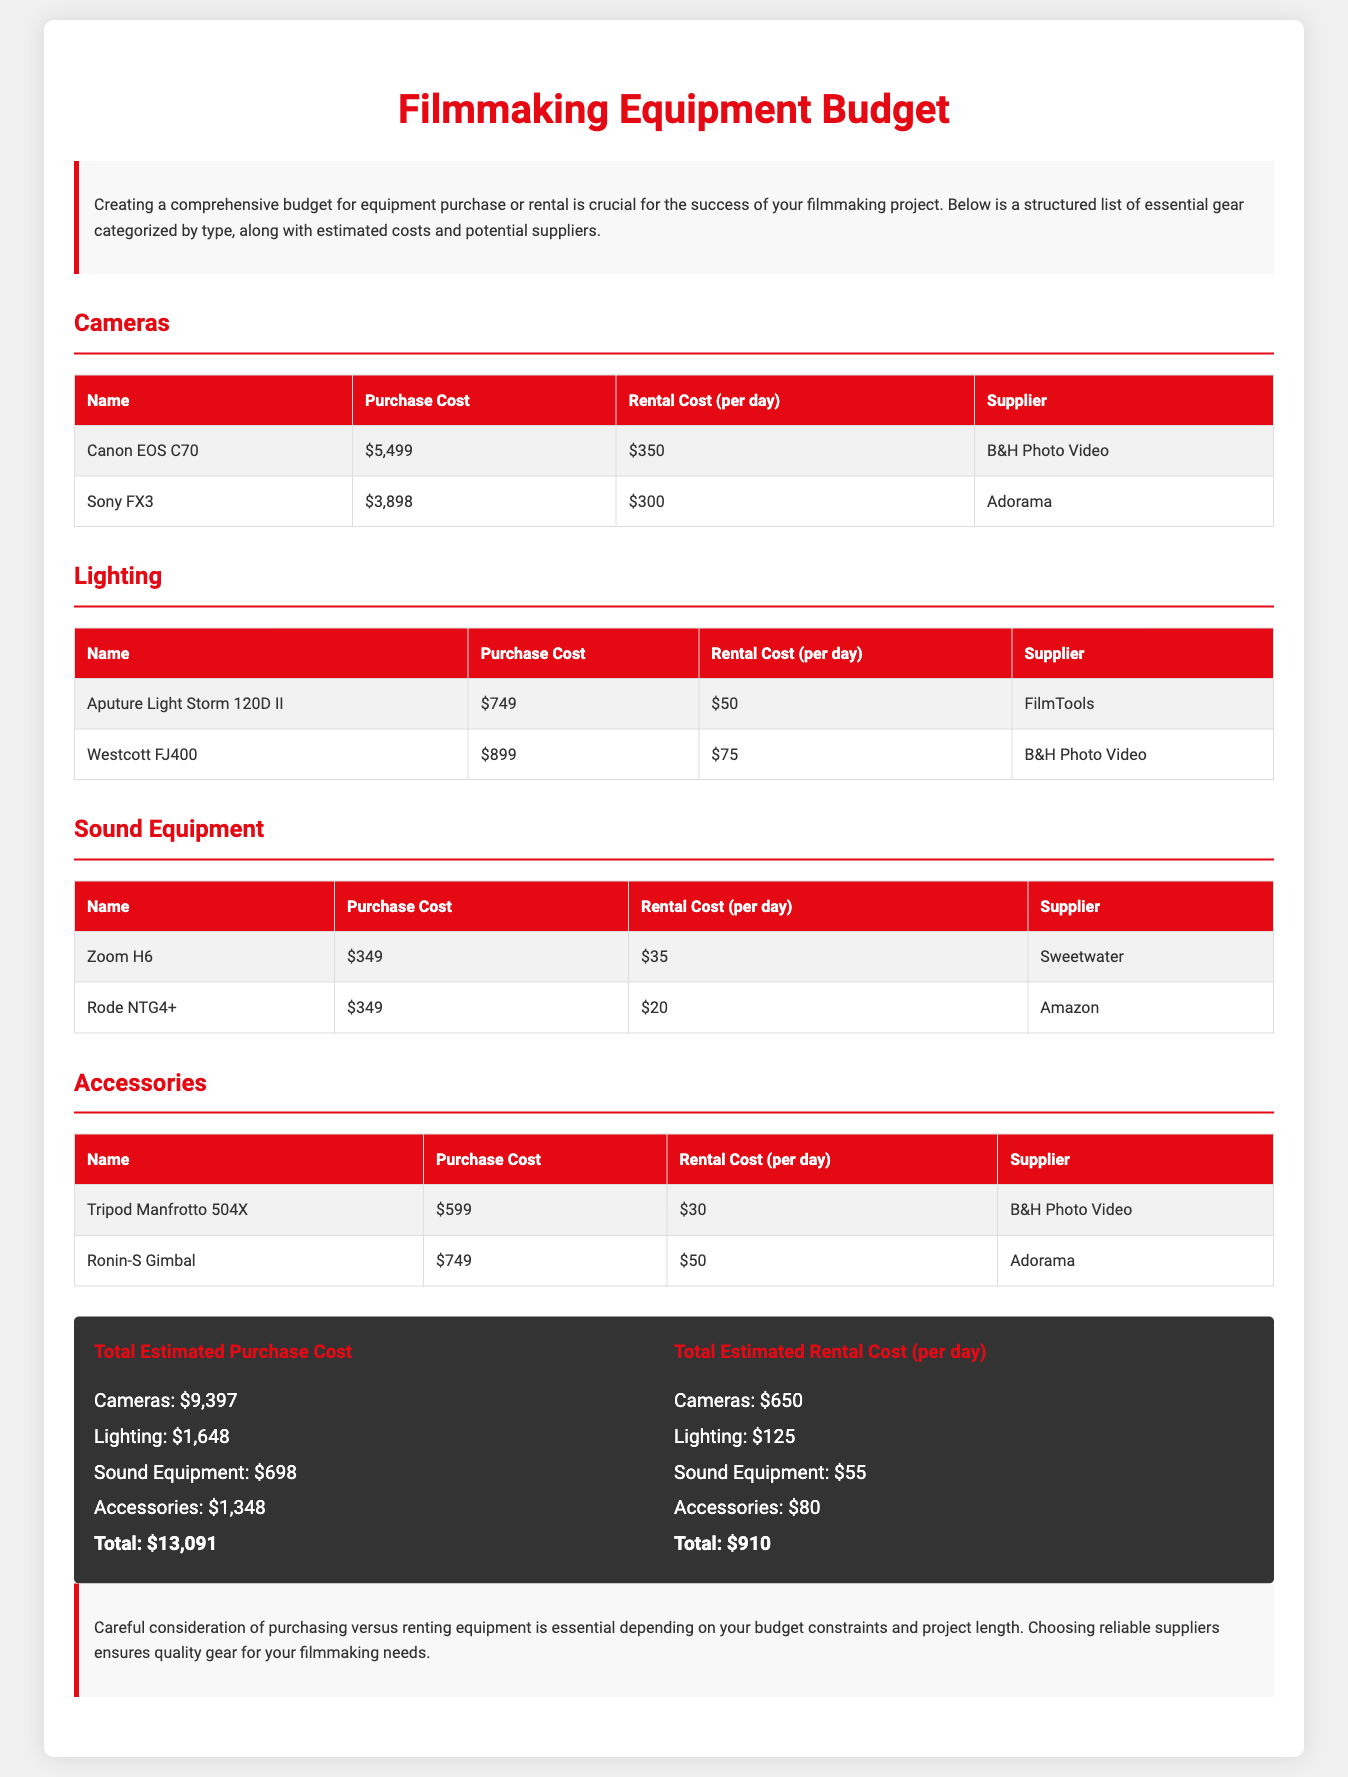What is the purchase cost of the Canon EOS C70? The purchase cost of the Canon EOS C70 is listed in the document as $5,499.
Answer: $5,499 What is the rental cost per day for the Rode NTG4+? The rental cost per day for the Rode NTG4+ is specified as $20 in the sound equipment section.
Answer: $20 How much does the Aputure Light Storm 120D II cost to purchase? The Aputure Light Storm 120D II has a purchase cost of $749 according to the document.
Answer: $749 What is the total estimated purchase cost for cameras? The total estimated purchase cost for cameras is the sum of camera prices which is calculated to be $9,397.
Answer: $9,397 Name one supplier for lighting equipment. One of the suppliers for lighting equipment mentioned in the document is B&H Photo Video.
Answer: B&H Photo Video What is the total estimated rental cost per day? The total estimated rental cost per day is the sum of all rental costs in the document, which amounts to $910.
Answer: $910 How much does it cost to rent the Tripod Manfrotto 504X per day? The rental cost per day for the Tripod Manfrotto 504X is specified as $30.
Answer: $30 What is the purchase cost of the Ronin-S Gimbal? The purchase cost of the Ronin-S Gimbal is listed as $749 in the accessories section.
Answer: $749 Who sells the Zoom H6? The supplier for the Zoom H6 as mentioned in the document is Sweetwater.
Answer: Sweetwater 